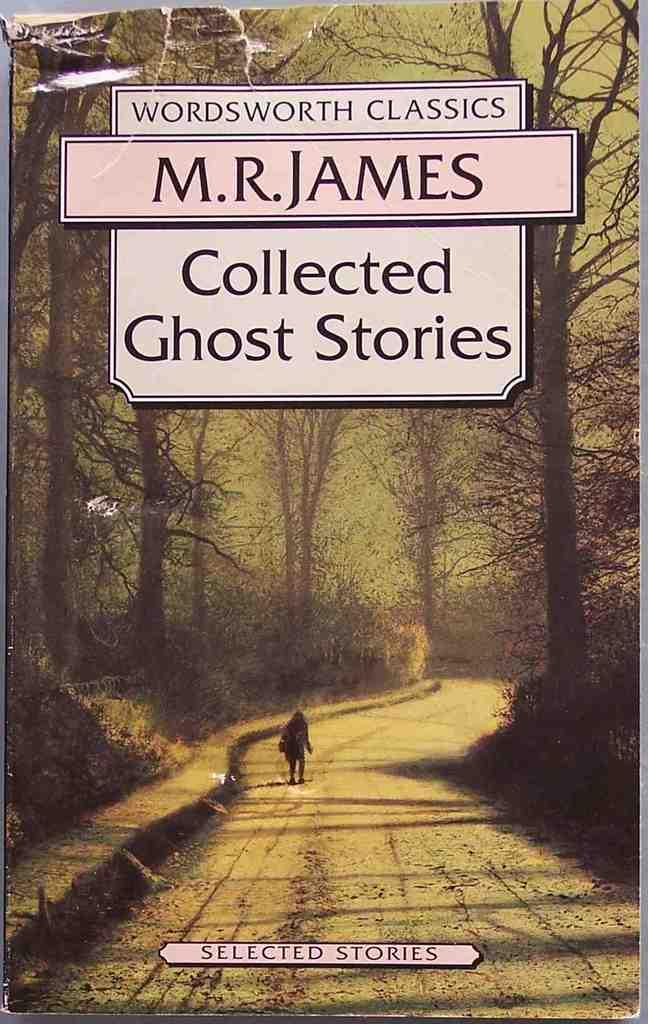Who is the author?
Provide a short and direct response. M.r. james. 